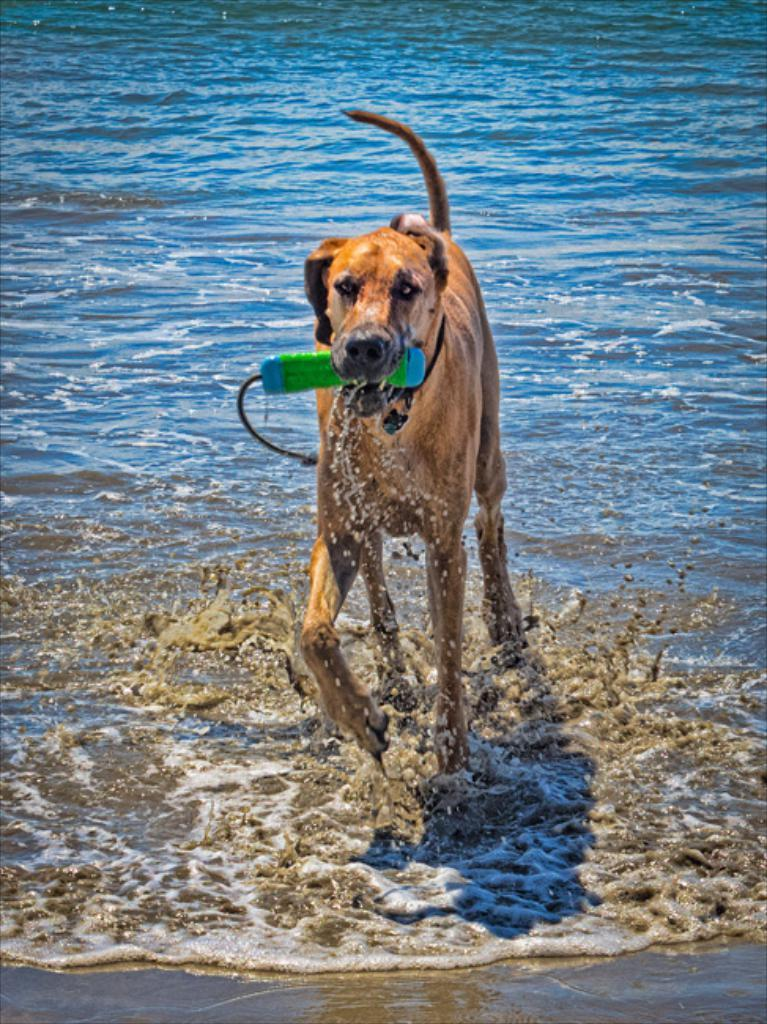What animal can be seen in the picture? There is a dog in the picture. What is the dog holding in its mouth? The dog is holding a green bottle in its mouth. What can be seen in the background of the picture? There is water visible in the background of the picture. What type of acoustics can be heard from the dog's brain in the image? There is no indication of the dog's brain or any acoustics in the image. 